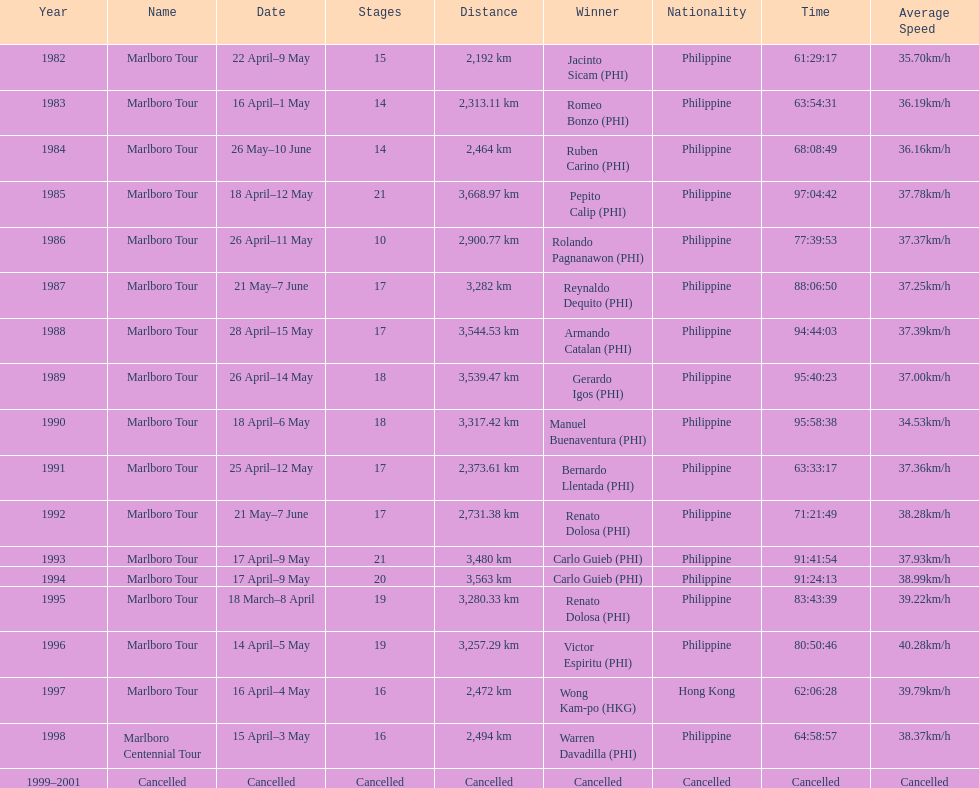Who is listed below romeo bonzo? Ruben Carino (PHI). 